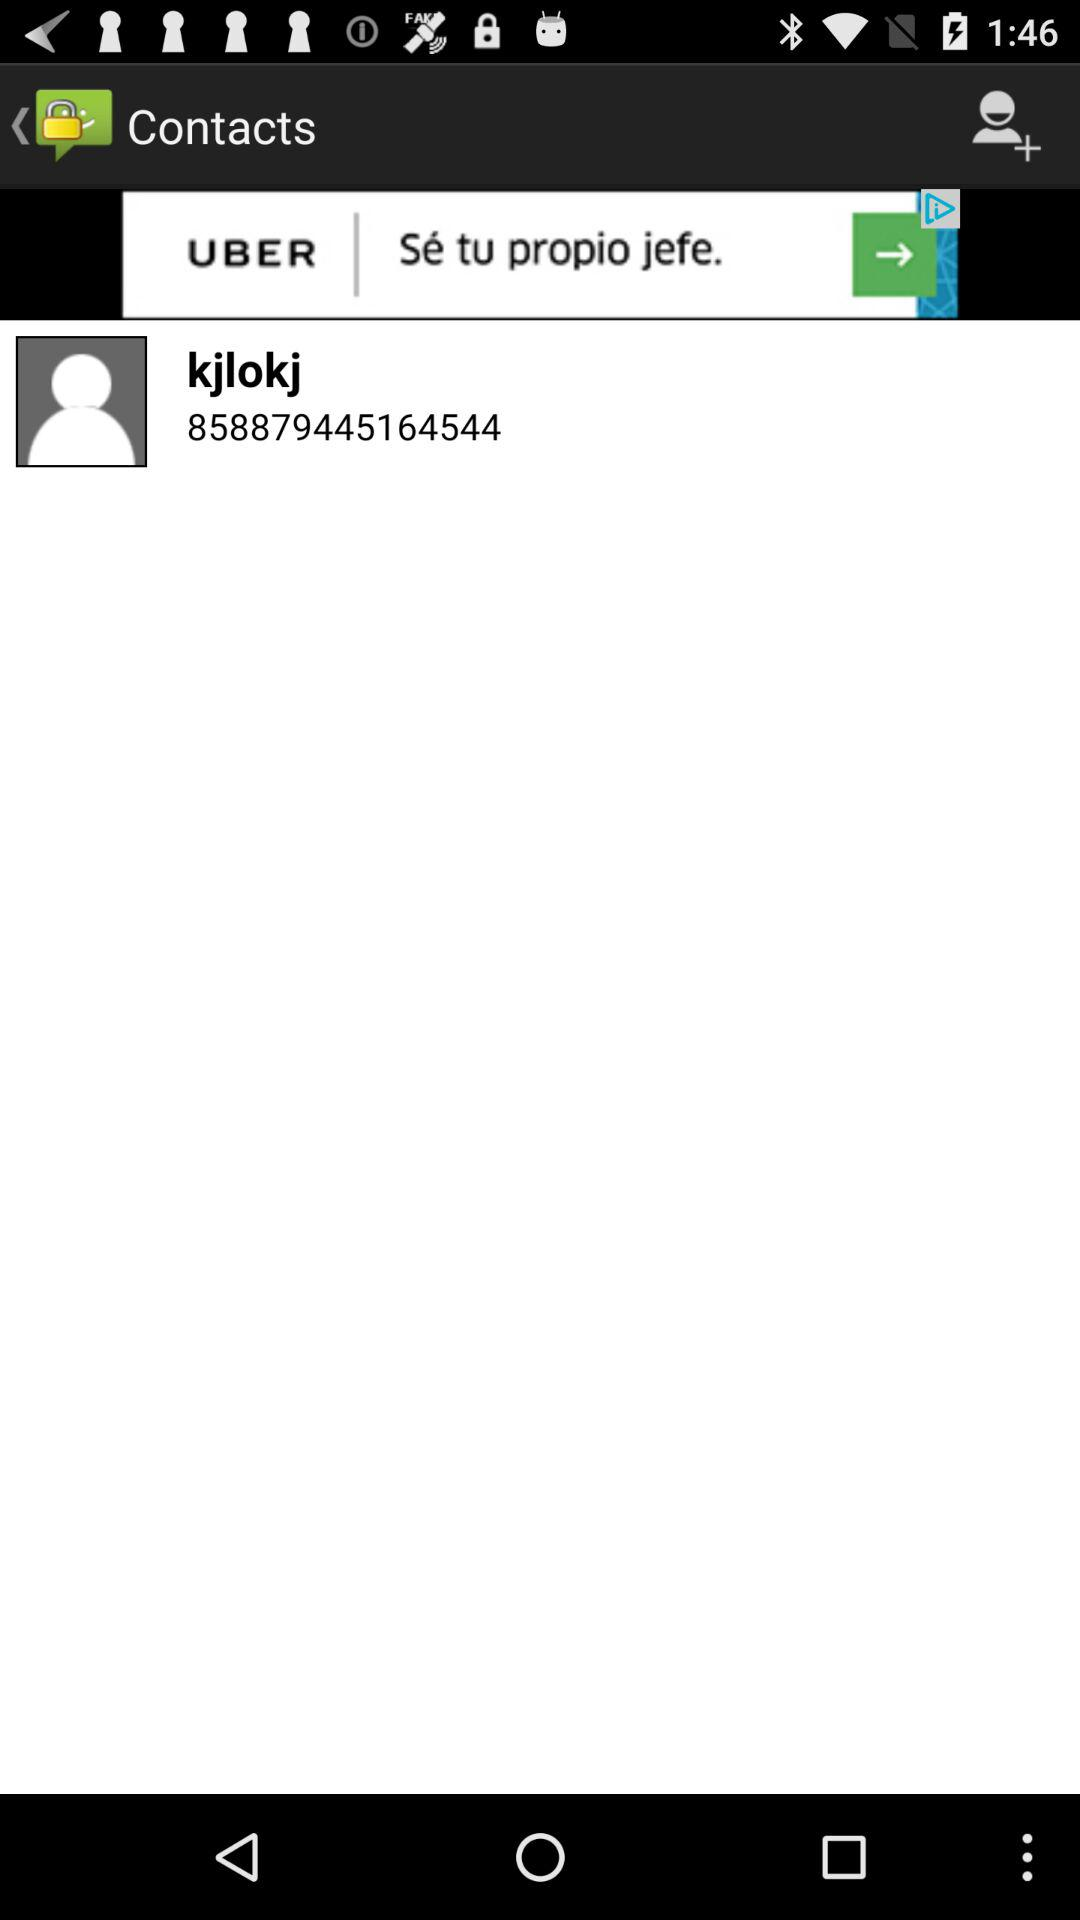What's the contact number? The contact number is 858879445164544. 